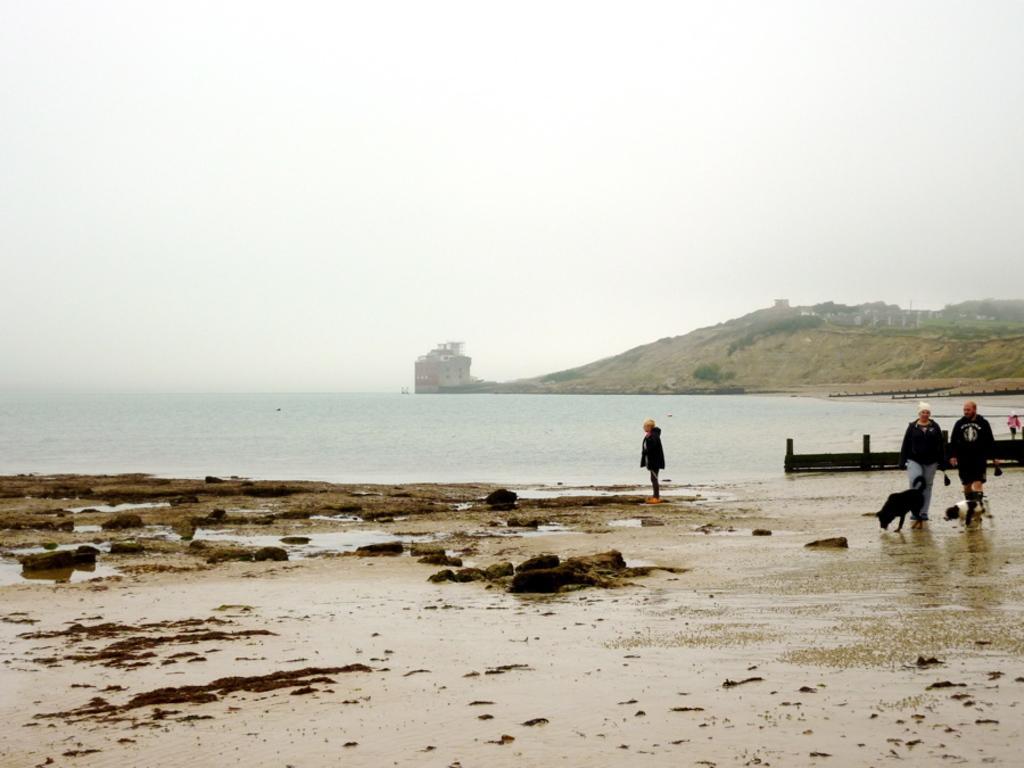How would you summarize this image in a sentence or two? This picture is clicked outside. On the right we can see the group of people and we can see the animals. In the foreground we can see the ground and the rocks. In the center we can see a water body. In the background we can see the sky, hills, houses and some other items. 